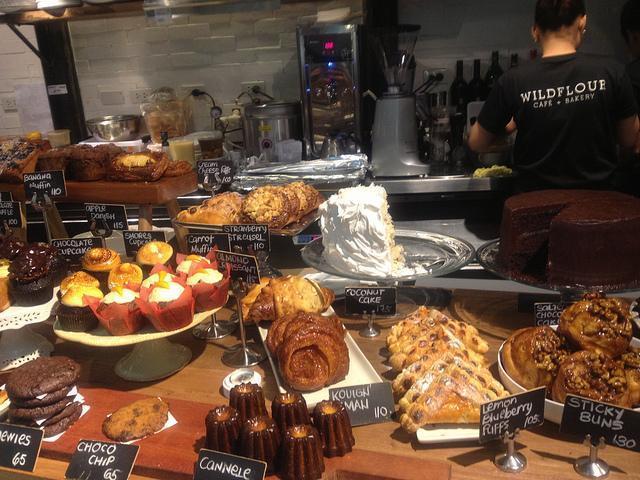How many donuts are visible?
Give a very brief answer. 2. How many cakes are there?
Give a very brief answer. 3. How many little elephants are in the image?
Give a very brief answer. 0. 